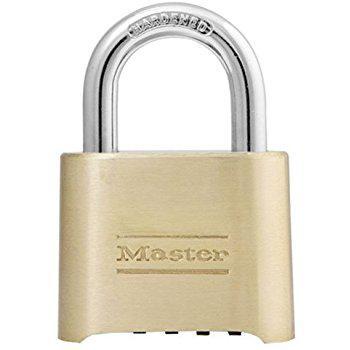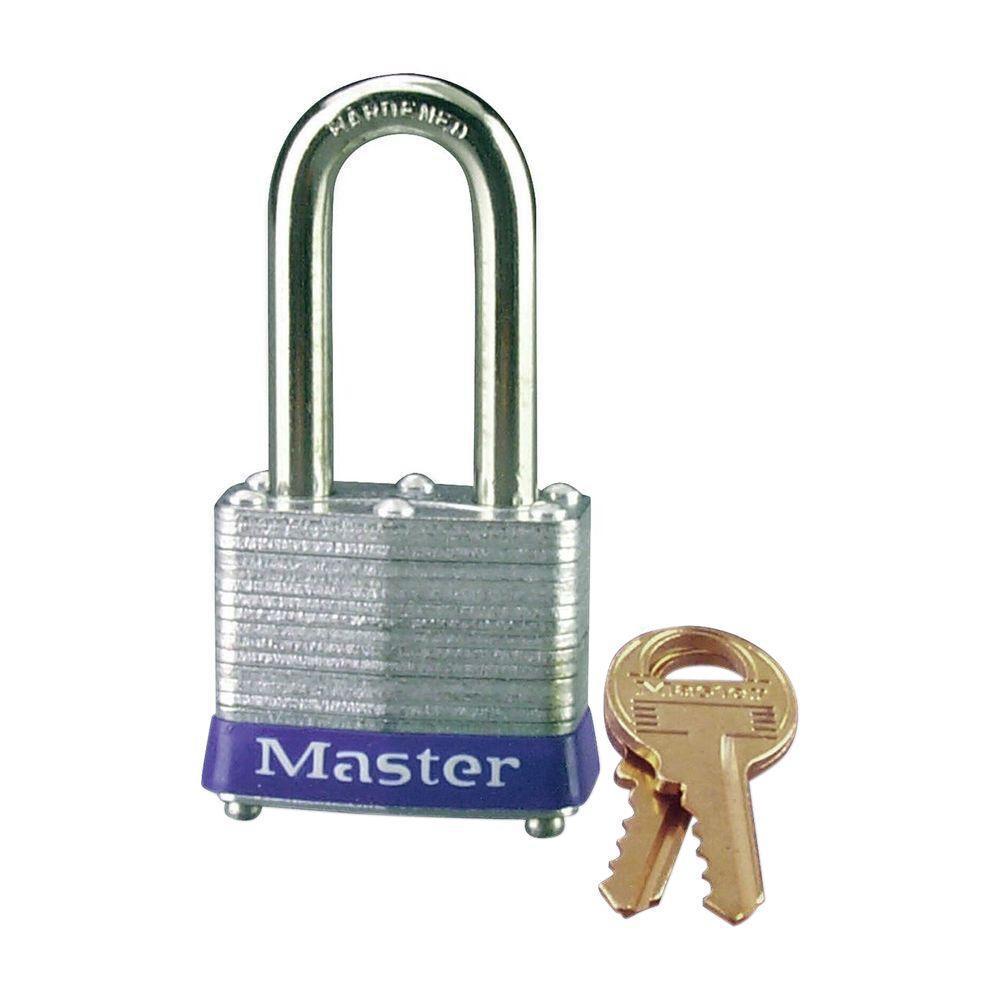The first image is the image on the left, the second image is the image on the right. Considering the images on both sides, is "At least one of the padlocks is numbered." valid? Answer yes or no. No. The first image is the image on the left, the second image is the image on the right. Analyze the images presented: Is the assertion "Two gold keys sit to the right of a silver padlock with a blue base." valid? Answer yes or no. Yes. 